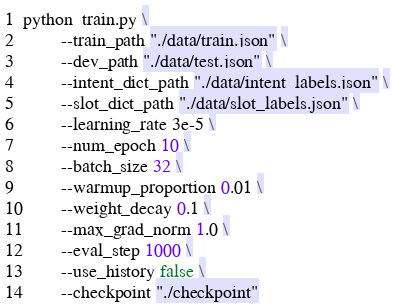<code> <loc_0><loc_0><loc_500><loc_500><_Bash_>python  train.py \
        --train_path "./data/train.json" \
        --dev_path "./data/test.json" \
        --intent_dict_path "./data/intent_labels.json" \
        --slot_dict_path "./data/slot_labels.json" \
        --learning_rate 3e-5 \
        --num_epoch 10 \
        --batch_size 32 \
        --warmup_proportion 0.01 \
        --weight_decay 0.1 \
        --max_grad_norm 1.0 \
        --eval_step 1000 \
        --use_history false \
        --checkpoint "./checkpoint"


</code> 